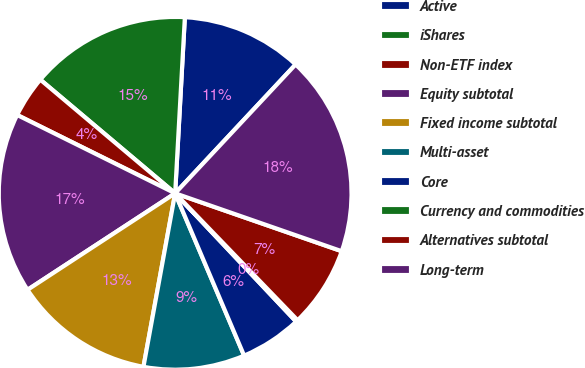Convert chart. <chart><loc_0><loc_0><loc_500><loc_500><pie_chart><fcel>Active<fcel>iShares<fcel>Non-ETF index<fcel>Equity subtotal<fcel>Fixed income subtotal<fcel>Multi-asset<fcel>Core<fcel>Currency and commodities<fcel>Alternatives subtotal<fcel>Long-term<nl><fcel>11.09%<fcel>14.73%<fcel>3.82%<fcel>16.54%<fcel>12.91%<fcel>9.27%<fcel>5.64%<fcel>0.18%<fcel>7.46%<fcel>18.36%<nl></chart> 